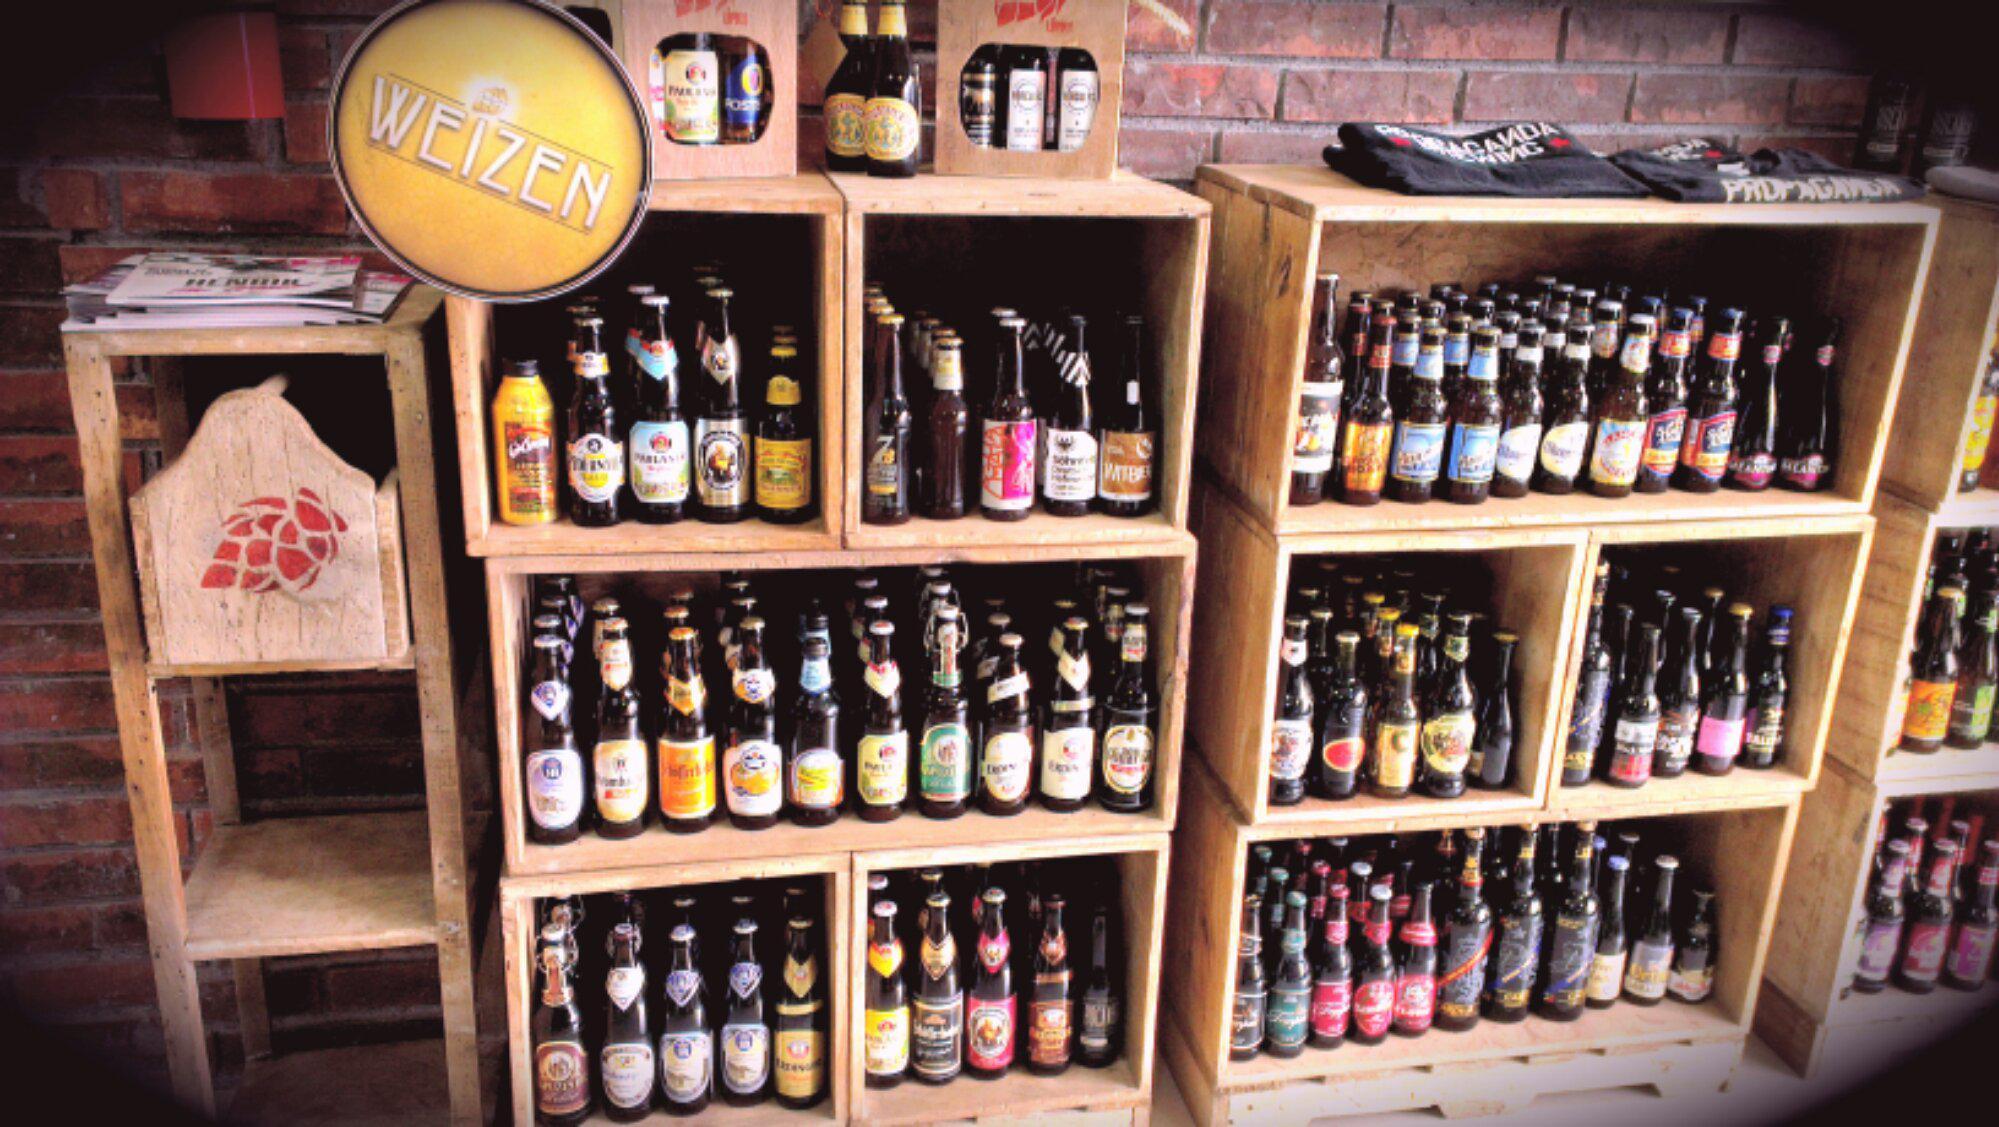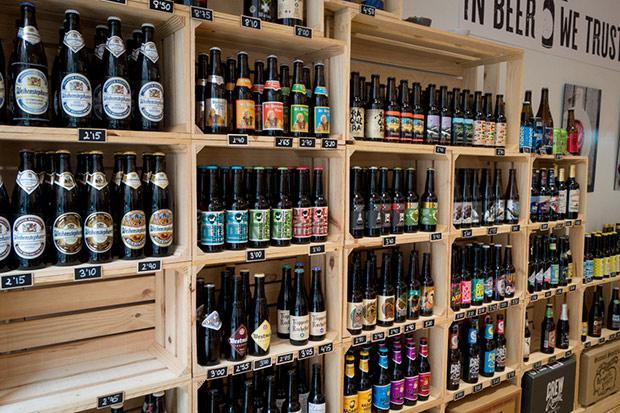The first image is the image on the left, the second image is the image on the right. Assess this claim about the two images: "In at least one image there are at least two sets of shelves holding at least three levels of beer bottles.". Correct or not? Answer yes or no. Yes. The first image is the image on the left, the second image is the image on the right. Assess this claim about the two images: "All of the beer is on shelving.". Correct or not? Answer yes or no. Yes. 